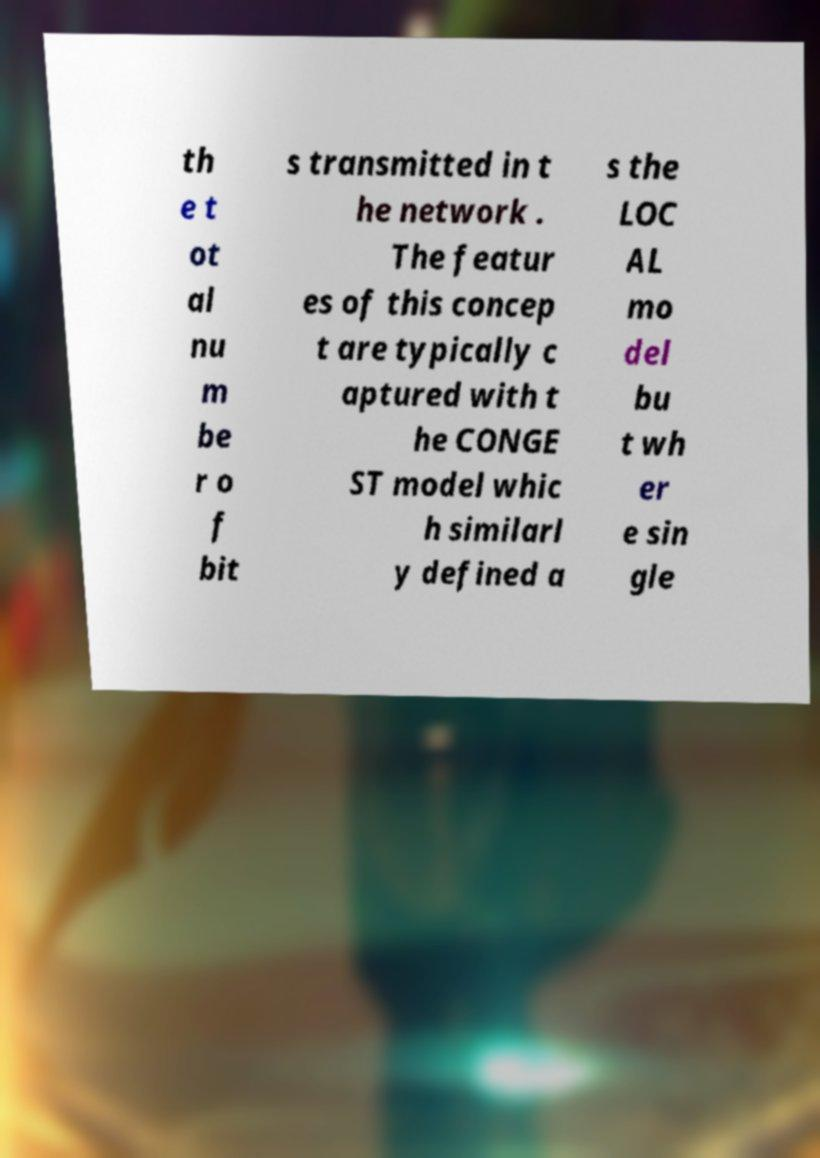Can you accurately transcribe the text from the provided image for me? th e t ot al nu m be r o f bit s transmitted in t he network . The featur es of this concep t are typically c aptured with t he CONGE ST model whic h similarl y defined a s the LOC AL mo del bu t wh er e sin gle 